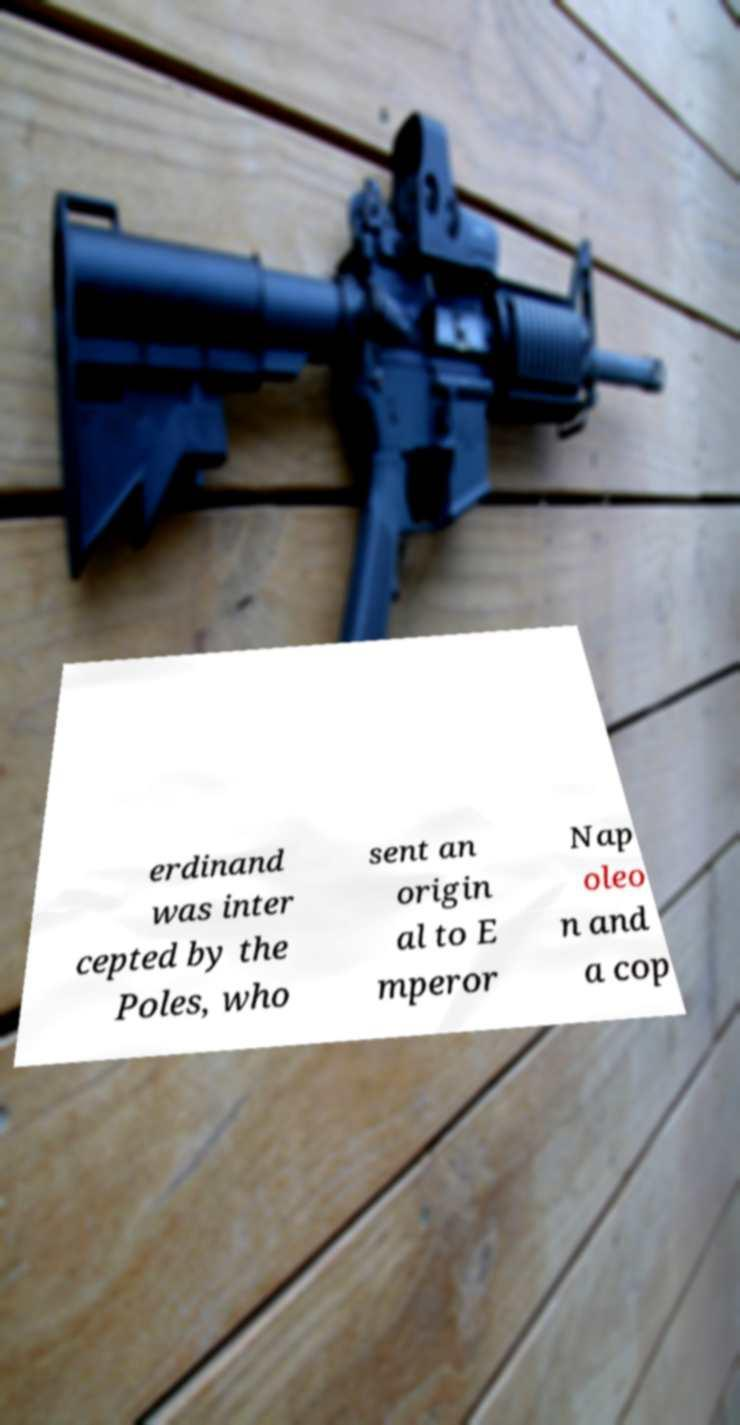For documentation purposes, I need the text within this image transcribed. Could you provide that? erdinand was inter cepted by the Poles, who sent an origin al to E mperor Nap oleo n and a cop 